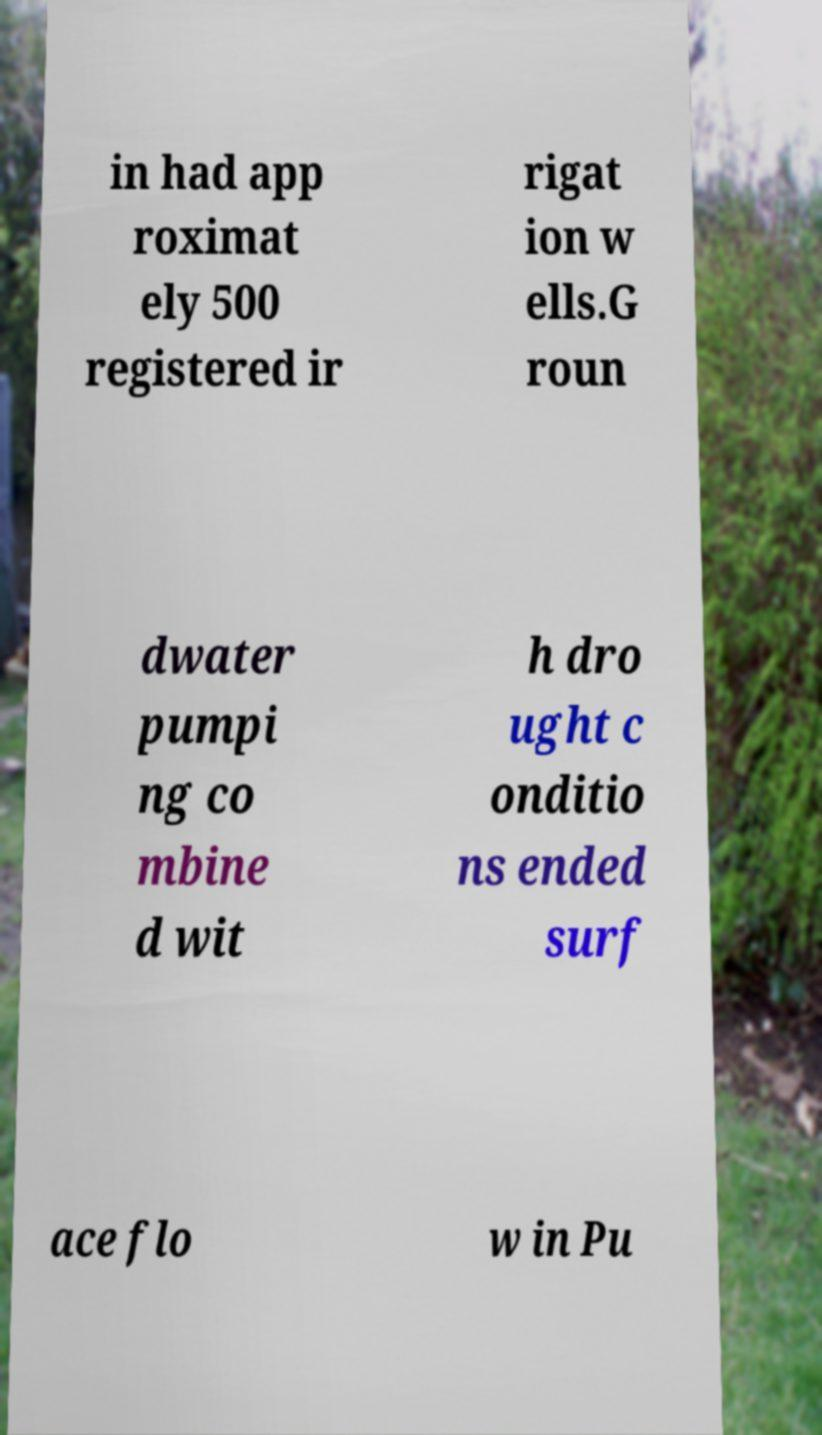Could you extract and type out the text from this image? in had app roximat ely 500 registered ir rigat ion w ells.G roun dwater pumpi ng co mbine d wit h dro ught c onditio ns ended surf ace flo w in Pu 